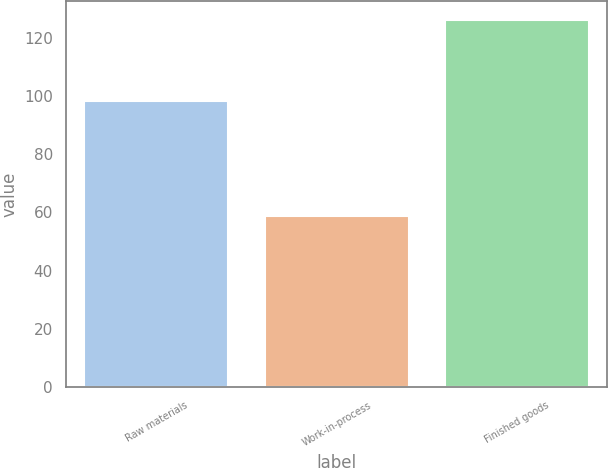<chart> <loc_0><loc_0><loc_500><loc_500><bar_chart><fcel>Raw materials<fcel>Work-in-process<fcel>Finished goods<nl><fcel>98.3<fcel>58.7<fcel>126.1<nl></chart> 